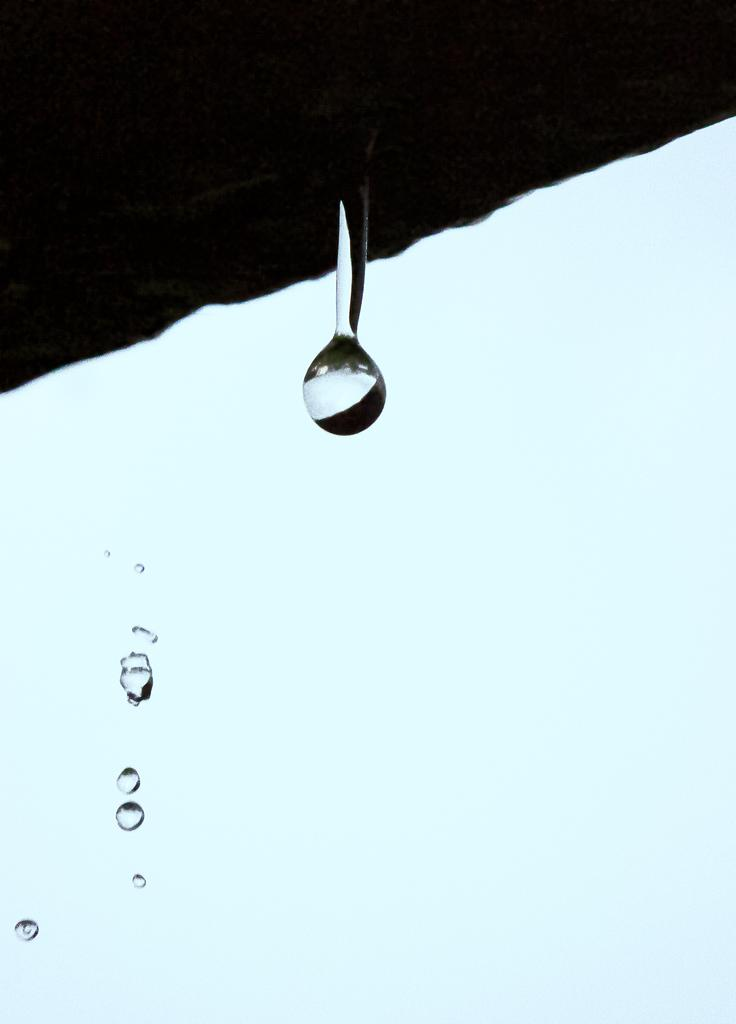What can be seen in the air in the image? There are water droplets in the air in the image. What structure is visible in the image? There is a roof visible in the image. What part of the natural environment is visible in the image? The sky is visible in the image. Where is the rod placed in the image? There is no rod present in the image. What type of desk can be seen in the image? There is no desk present in the image. 